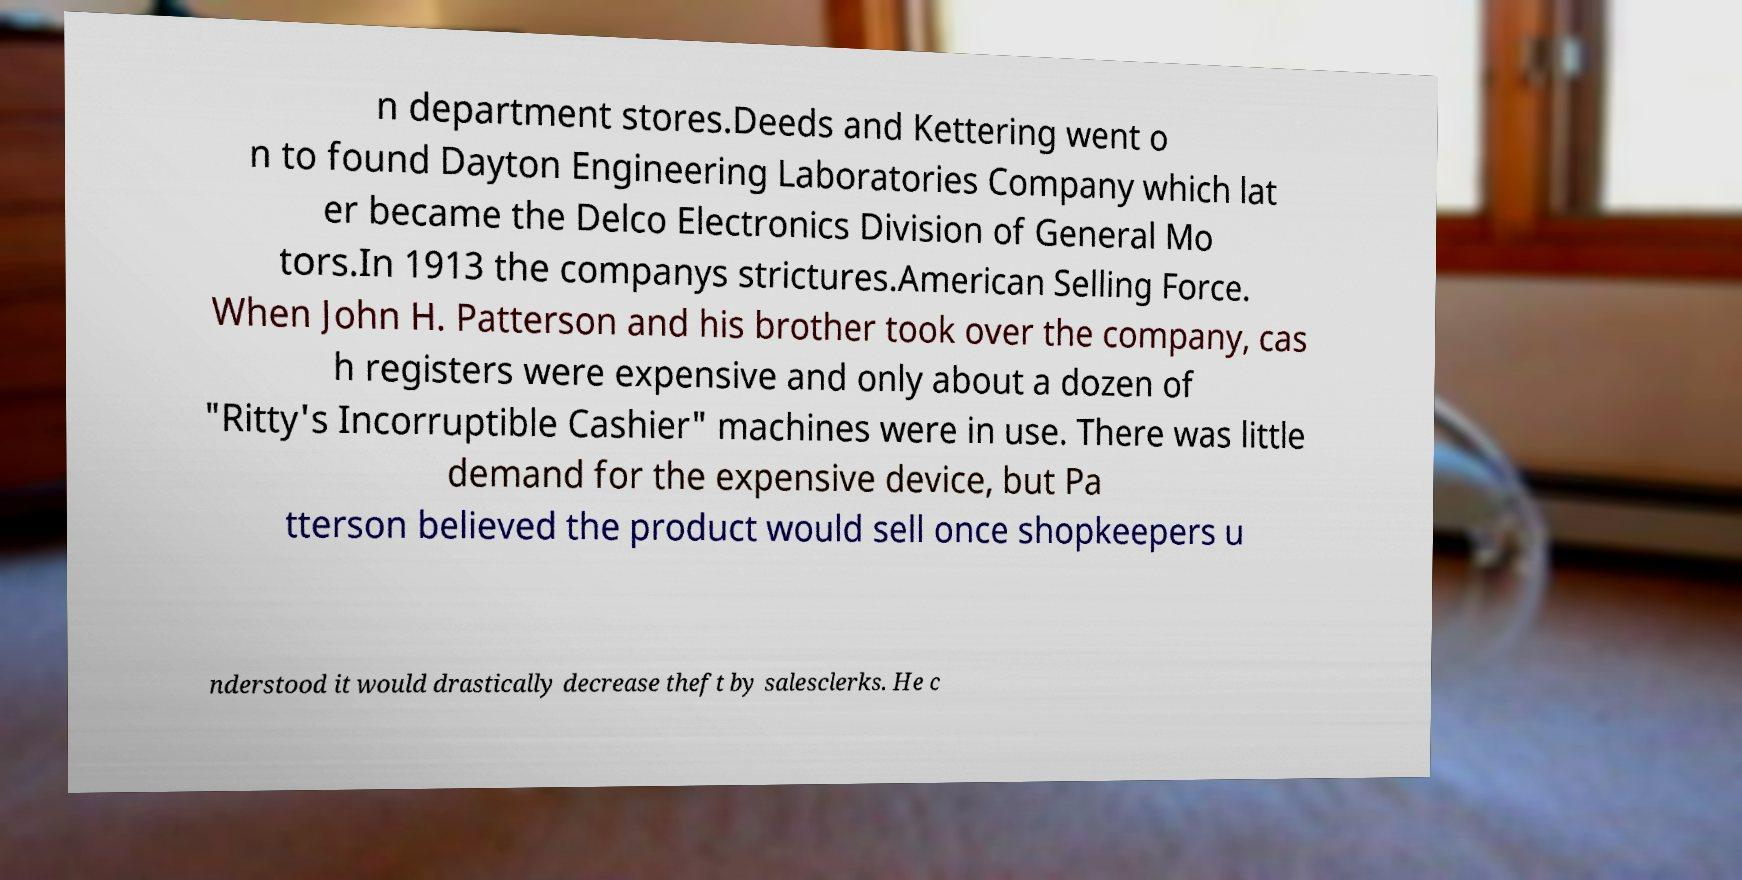Please read and relay the text visible in this image. What does it say? n department stores.Deeds and Kettering went o n to found Dayton Engineering Laboratories Company which lat er became the Delco Electronics Division of General Mo tors.In 1913 the companys strictures.American Selling Force. When John H. Patterson and his brother took over the company, cas h registers were expensive and only about a dozen of "Ritty's Incorruptible Cashier" machines were in use. There was little demand for the expensive device, but Pa tterson believed the product would sell once shopkeepers u nderstood it would drastically decrease theft by salesclerks. He c 